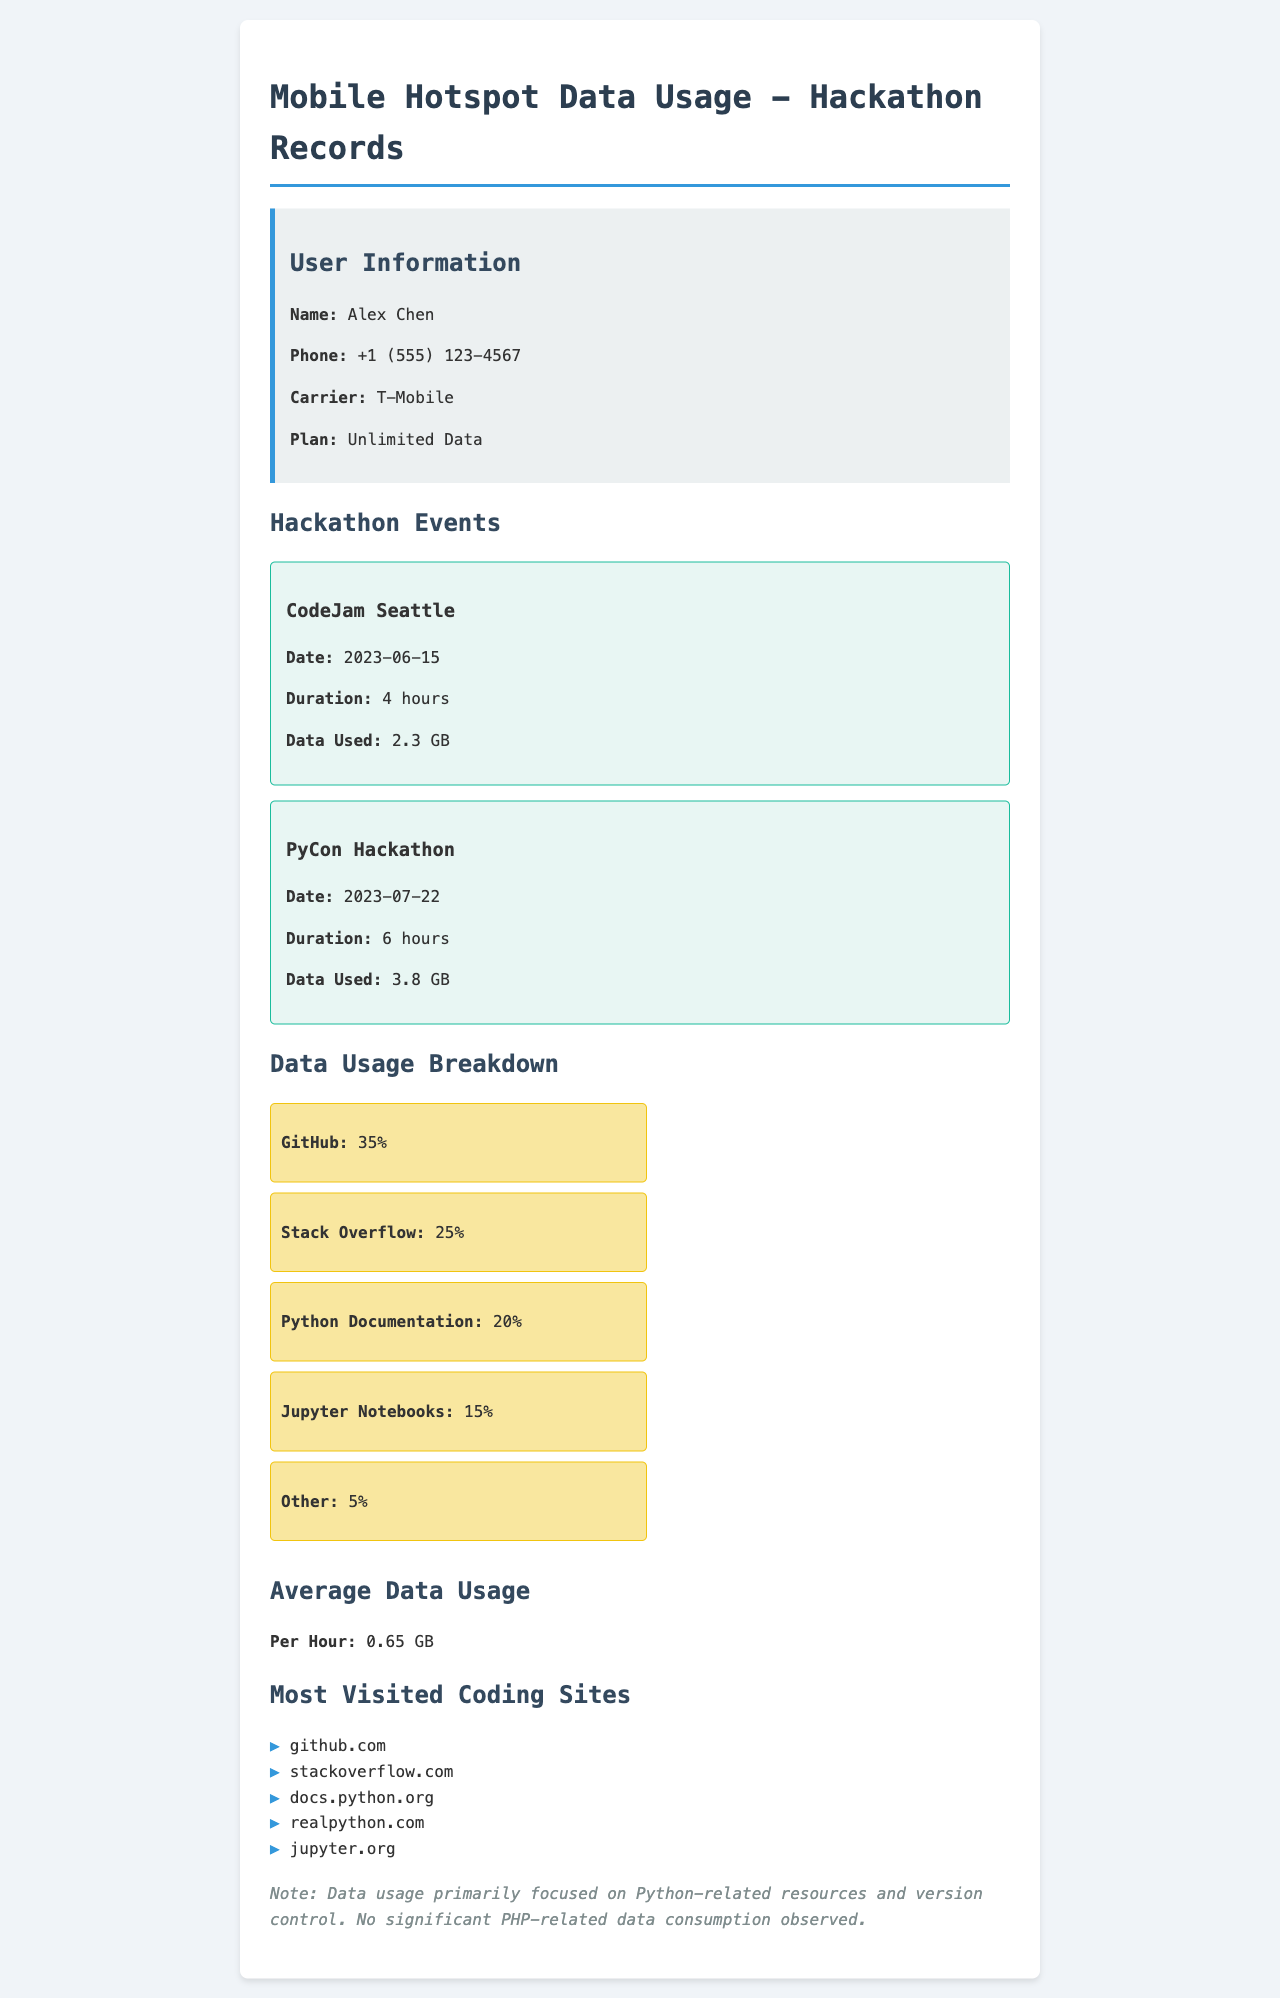What is the user's name? The user's name is explicitly stated in the user information section of the document.
Answer: Alex Chen What is the total data used during hackathons? The total data used is the sum of the data used for each hackathon. 2.3 GB + 3.8 GB = 6.1 GB.
Answer: 6.1 GB What event took place on July 22, 2023? The event name and date are specifically provided in the hackathon events section.
Answer: PyCon Hackathon What percentage of data was used for GitHub? The percentage of data used for GitHub is clearly listed in the data usage breakdown.
Answer: 35% What is the average data usage per hour? The average data usage per hour is mentioned directly in the average data usage section of the document.
Answer: 0.65 GB Which carrier is the user with? The carrier information is provided in the user information section.
Answer: T-Mobile What is the duration of the CodeJam Seattle event? The duration of the event is specified in hours within the hackathon event details.
Answer: 4 hours How many sites are listed in the most visited coding sites? The total number of sites is derived from counting the list of sites provided.
Answer: 5 What is the primary focus of data usage? The primary focus of data usage is mentioned in the note at the end of the document.
Answer: Python-related resources 